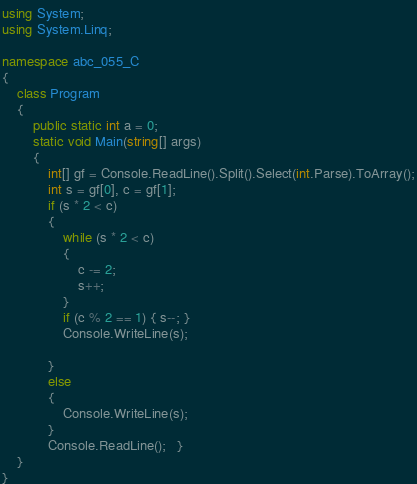<code> <loc_0><loc_0><loc_500><loc_500><_C#_>using System;
using System.Linq;

namespace abc_055_C
{
    class Program
    {
        public static int a = 0;
        static void Main(string[] args)
        {
            int[] gf = Console.ReadLine().Split().Select(int.Parse).ToArray();
            int s = gf[0], c = gf[1];
            if (s * 2 < c)
            {
                while (s * 2 < c)
                {
                    c -= 2;
                    s++;
                }
                if (c % 2 == 1) { s--; }
                Console.WriteLine(s);

            }
            else
            {
                Console.WriteLine(s);
            }
            Console.ReadLine();   }
    }
}</code> 